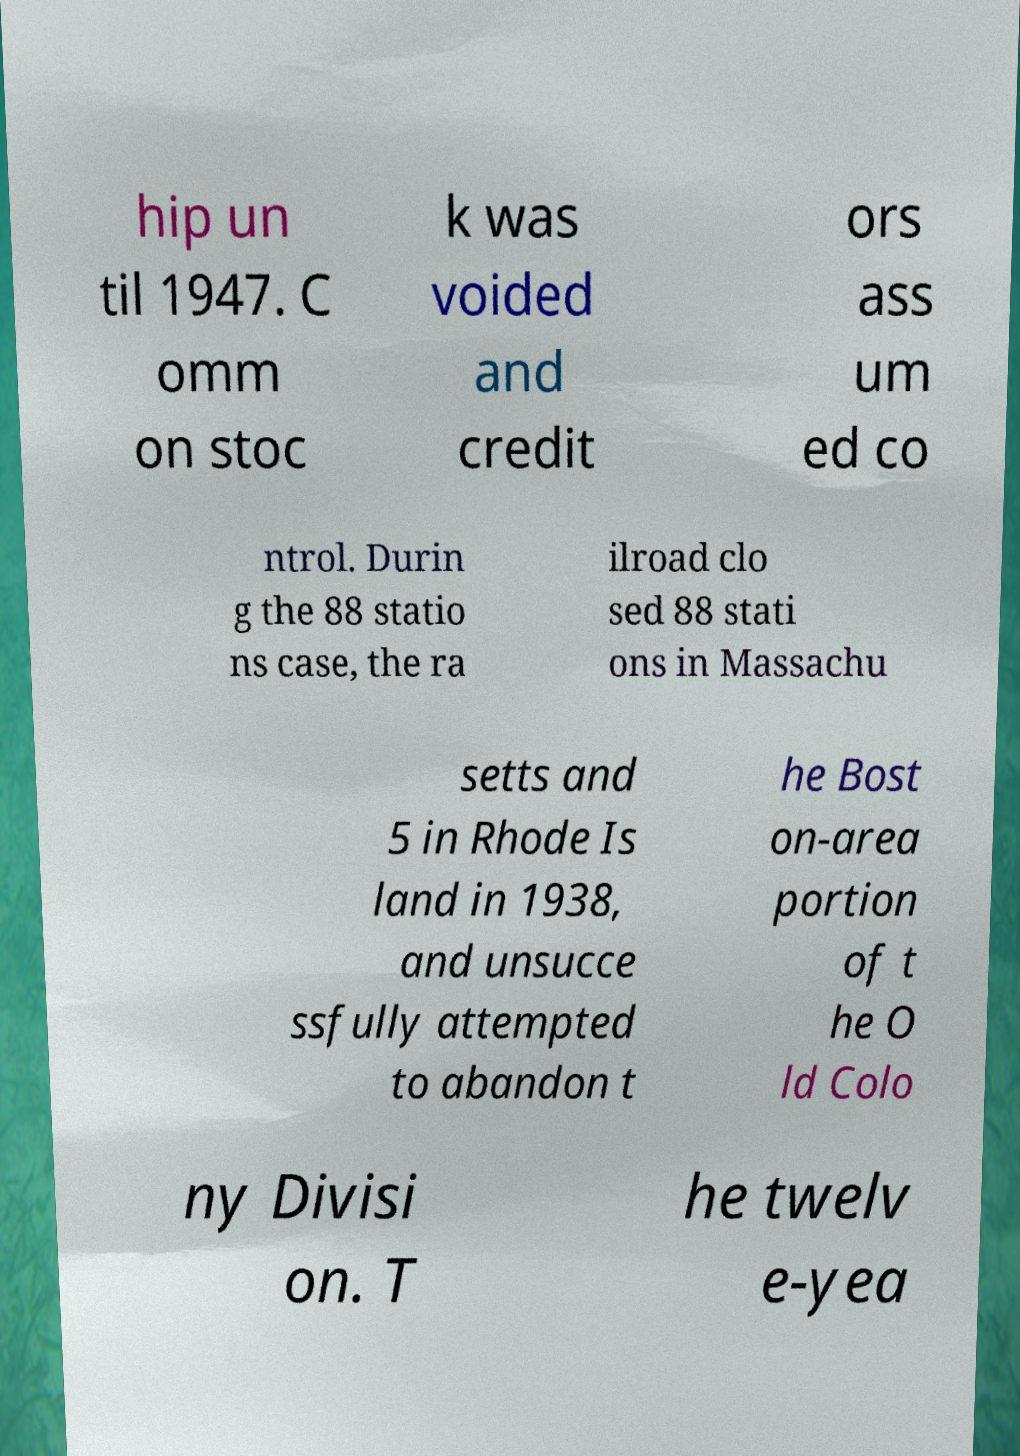There's text embedded in this image that I need extracted. Can you transcribe it verbatim? hip un til 1947. C omm on stoc k was voided and credit ors ass um ed co ntrol. Durin g the 88 statio ns case, the ra ilroad clo sed 88 stati ons in Massachu setts and 5 in Rhode Is land in 1938, and unsucce ssfully attempted to abandon t he Bost on-area portion of t he O ld Colo ny Divisi on. T he twelv e-yea 